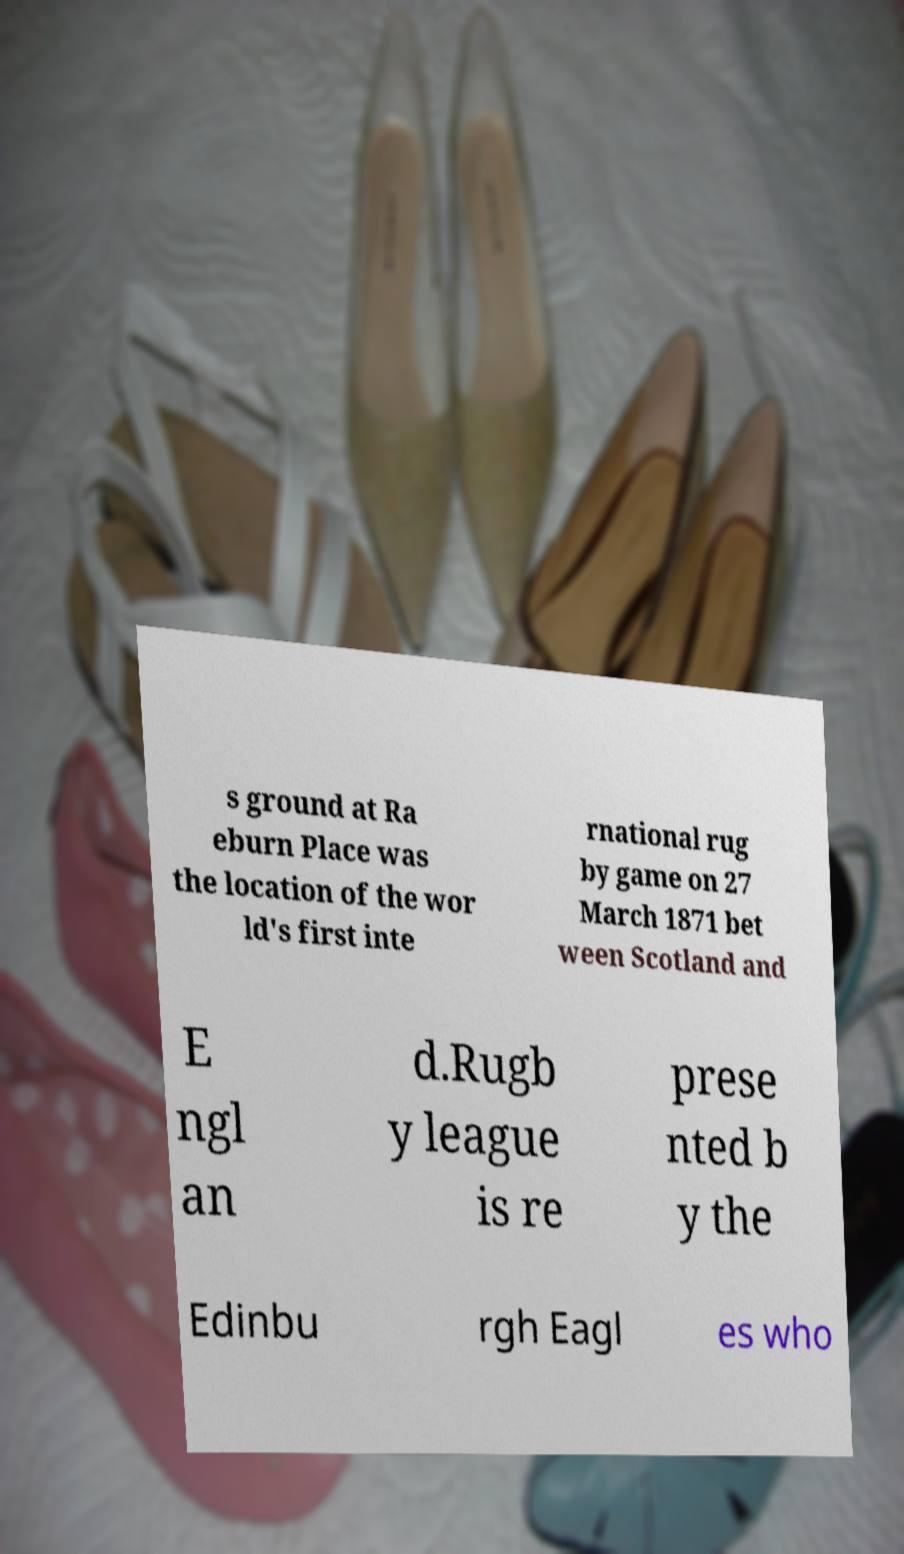Could you assist in decoding the text presented in this image and type it out clearly? s ground at Ra eburn Place was the location of the wor ld's first inte rnational rug by game on 27 March 1871 bet ween Scotland and E ngl an d.Rugb y league is re prese nted b y the Edinbu rgh Eagl es who 